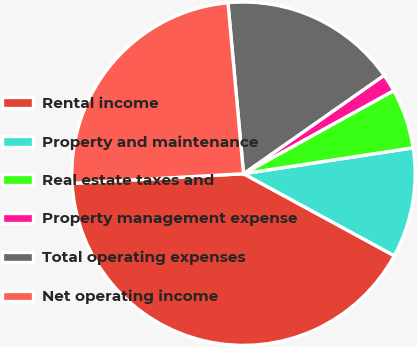Convert chart to OTSL. <chart><loc_0><loc_0><loc_500><loc_500><pie_chart><fcel>Rental income<fcel>Property and maintenance<fcel>Real estate taxes and<fcel>Property management expense<fcel>Total operating expenses<fcel>Net operating income<nl><fcel>41.17%<fcel>10.34%<fcel>5.63%<fcel>1.68%<fcel>16.72%<fcel>24.45%<nl></chart> 